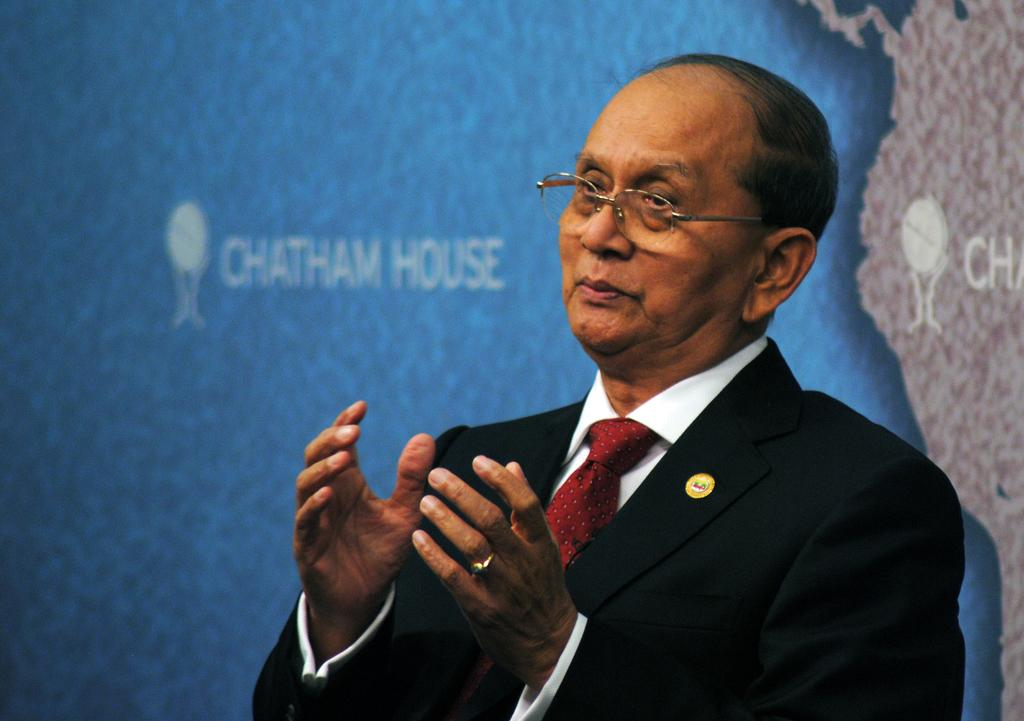Who is present in the image? There is a man in the image. What is the man wearing? The man is wearing a suit and a tie. What can be seen in the background of the image? There is a map in the background of the image. What type of food is the man eating in the image? There is no food present in the image, so it cannot be determined what the man might be eating. 